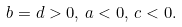<formula> <loc_0><loc_0><loc_500><loc_500>b = d > 0 , \, a < 0 , \, c < 0 .</formula> 